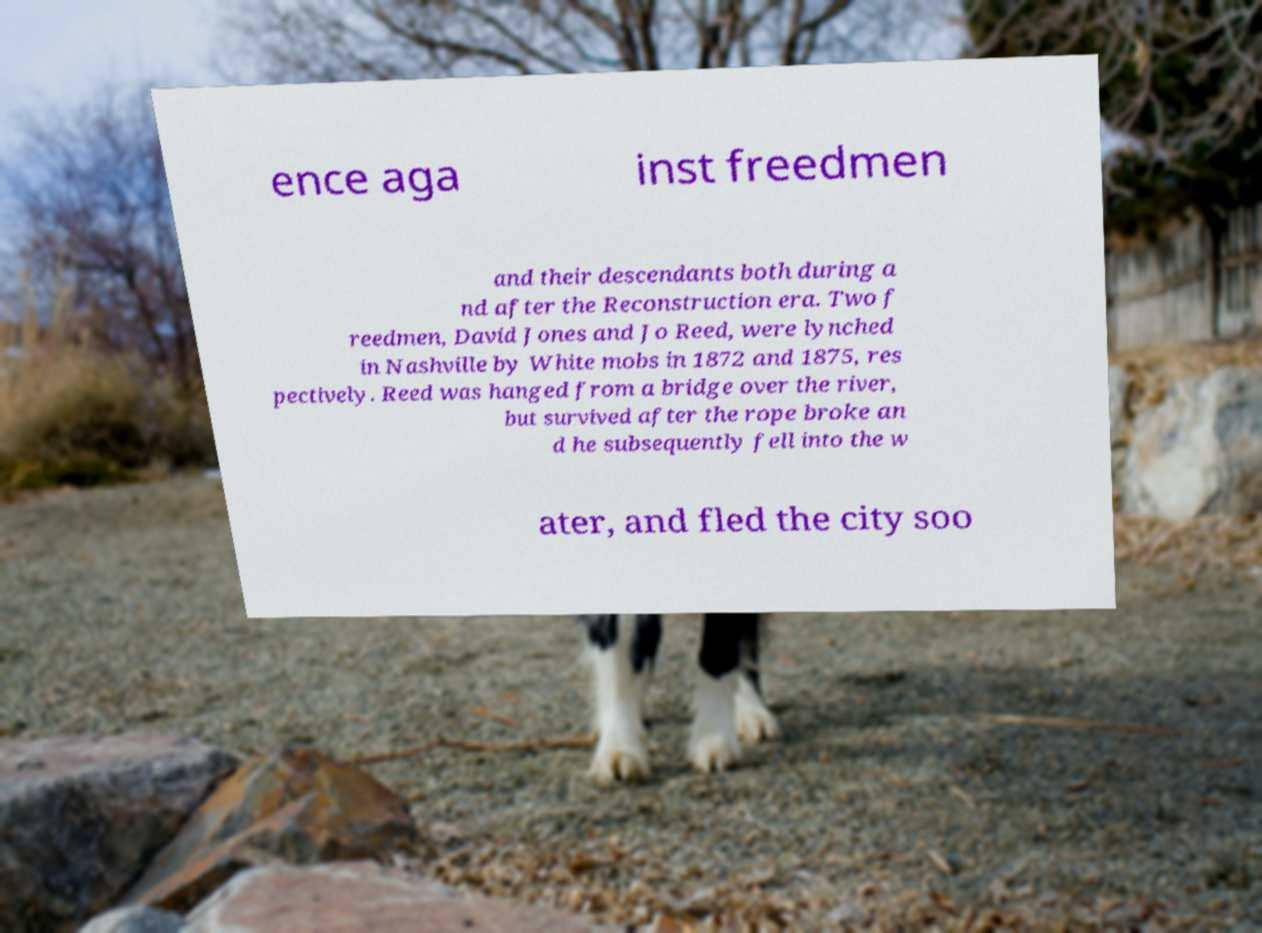There's text embedded in this image that I need extracted. Can you transcribe it verbatim? ence aga inst freedmen and their descendants both during a nd after the Reconstruction era. Two f reedmen, David Jones and Jo Reed, were lynched in Nashville by White mobs in 1872 and 1875, res pectively. Reed was hanged from a bridge over the river, but survived after the rope broke an d he subsequently fell into the w ater, and fled the city soo 